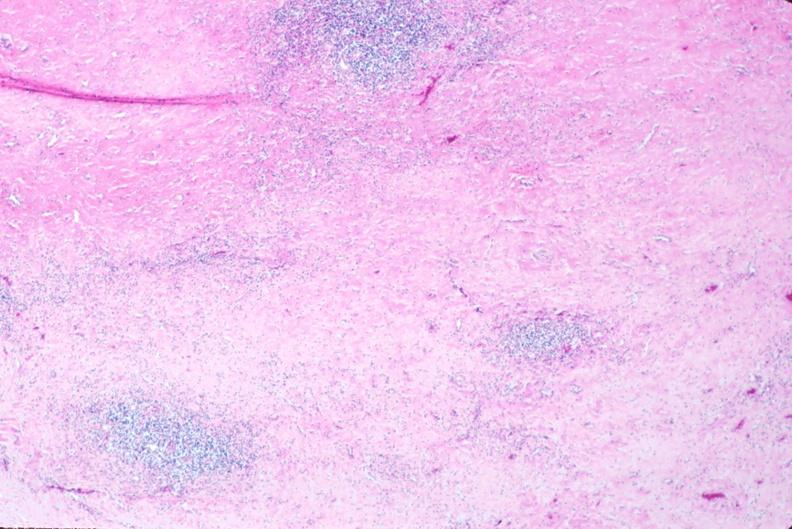does cephalohematoma show lymph nodes, nodular sclerosing hodgkins disease?
Answer the question using a single word or phrase. No 